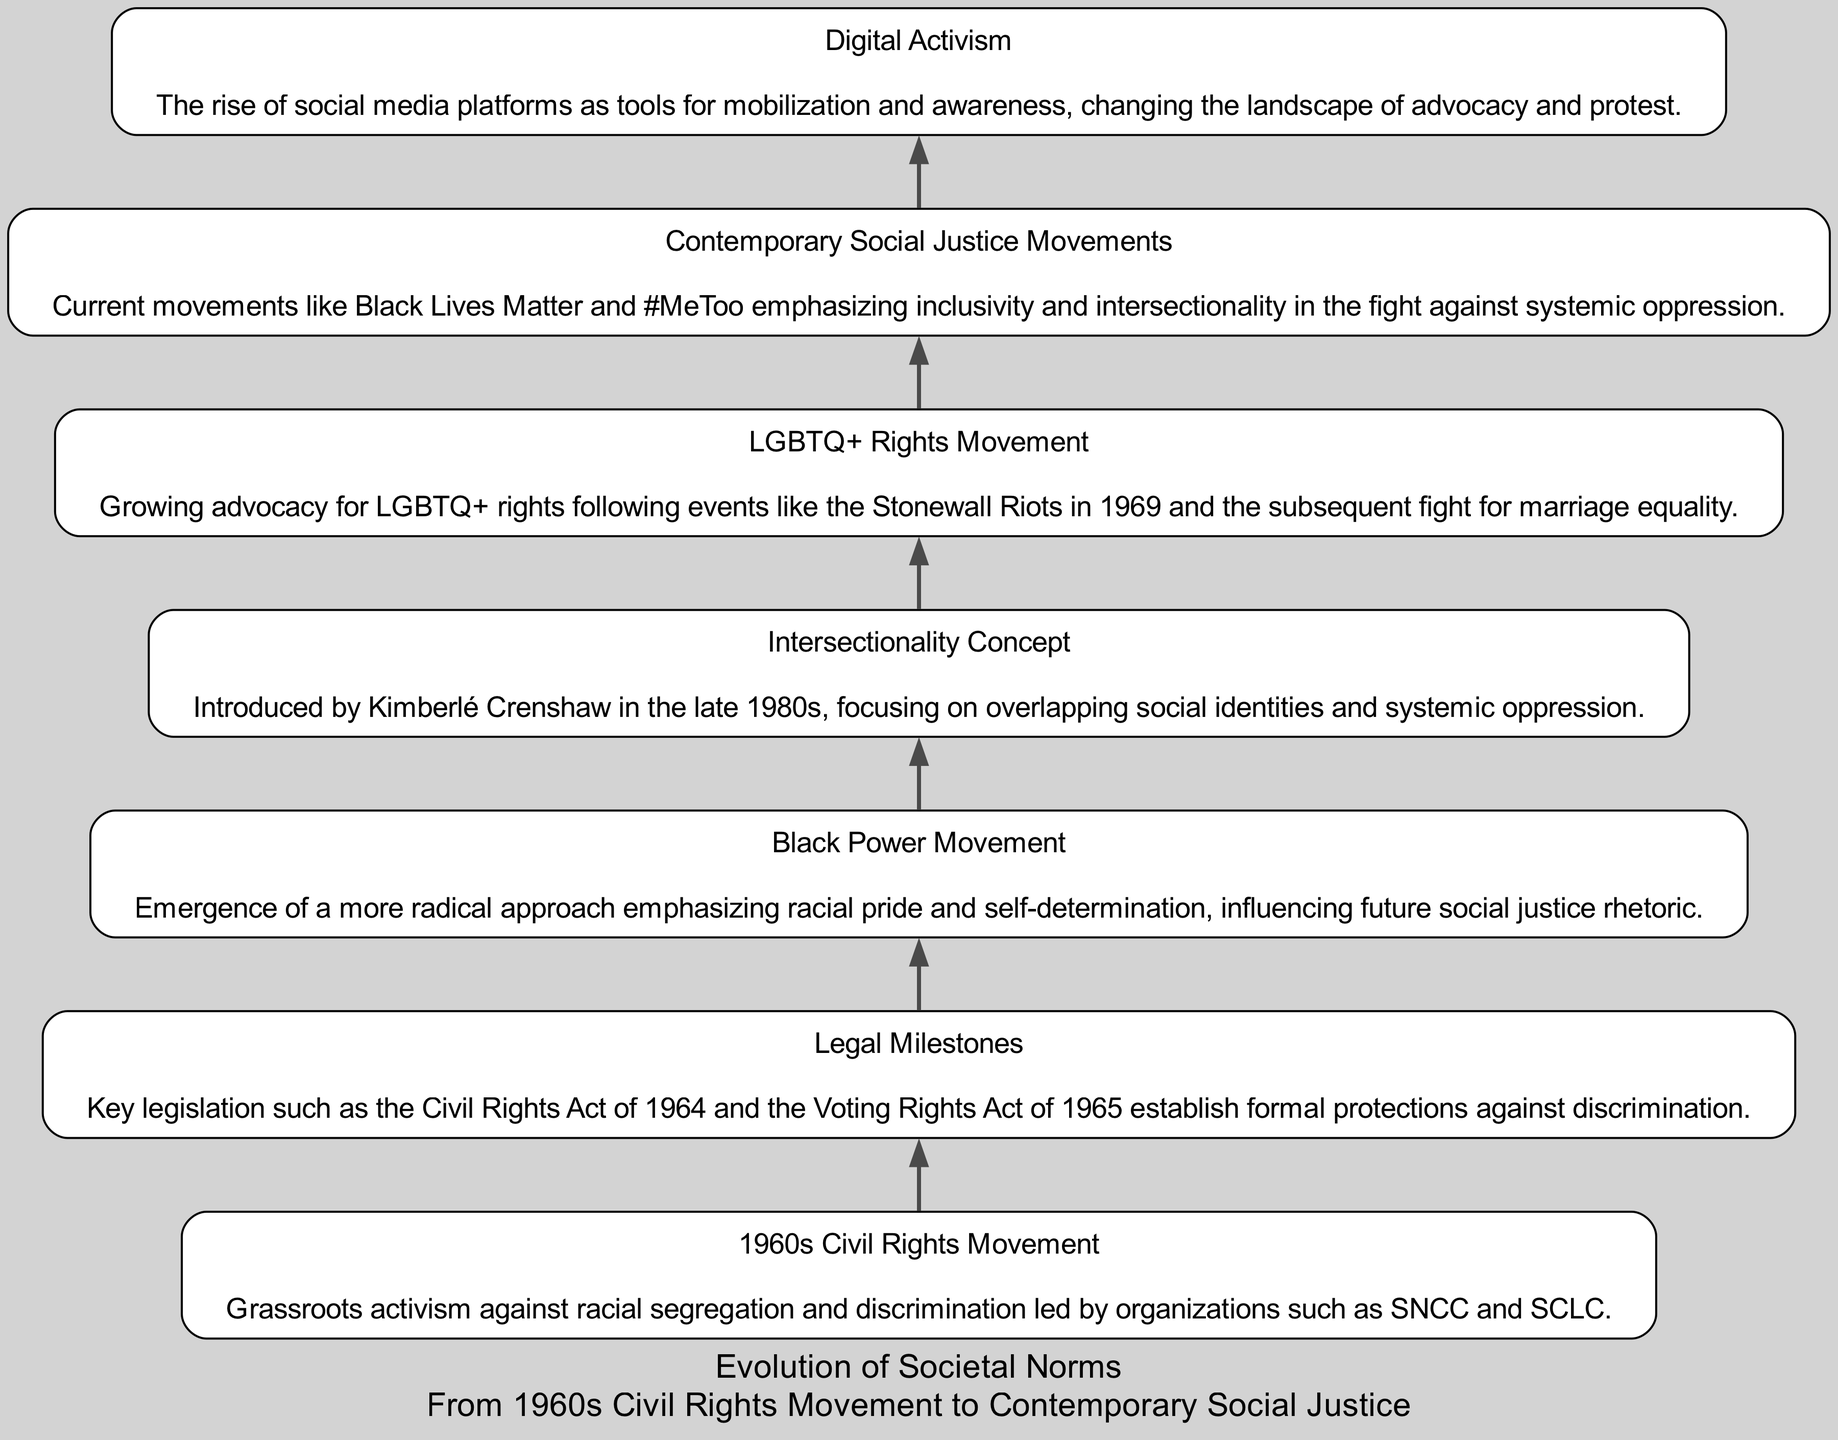What is the first node in the flow chart? The first node listed in the data corresponds to the "1960s Civil Rights Movement," which is the starting point of the diagram.
Answer: 1960s Civil Rights Movement How many nodes are present in the diagram? Counting each entry in the elements array, there are a total of seven nodes in the flow chart.
Answer: 7 Which node describes the concept introduced by Kimberlé Crenshaw? The node that mentions Kimberlé Crenshaw and her introduction of the concept is "Intersectionality Concept".
Answer: Intersectionality Concept What connects the "Black Power Movement" to "Legal Milestones"? The diagram flows sequentially, where "Black Power Movement" directly follows "Legal Milestones," suggesting a connection in the context of social progress.
Answer: The edge connecting the nodes What are the themes of the "Contemporary Social Justice Movements"? The node labeled "Contemporary Social Justice Movements" emphasizes inclusivity and intersectionality, reflecting modern themes in advocacy.
Answer: Inclusivity and intersectionality How does "Digital Activism" relate to "Contemporary Social Justice Movements"? "Digital Activism" is positioned below "Contemporary Social Justice Movements" in the diagram, indicating that the former serves as a tool for enhancing the latter's efforts.
Answer: Provides tools for mobilization Which node emphasizes a grassroots approach? The node "1960s Civil Rights Movement" explicitly describes a grassroots activism approach against racial segregation and discrimination.
Answer: 1960s Civil Rights Movement What is the significance of the "Black Power Movement" in relation to future movements? The description indicates that it influenced the rhetoric of future social justice movements by emphasizing racial pride and self-determination.
Answer: Influenced future social justice rhetoric What kind of movements follow after the "LGBTQ+ Rights Movement"? The flow of the chart indicates that both "Intersectionality Concept" and "Contemporary Social Justice Movements" follow after "LGBTQ+ Rights Movement," suggesting a continuation of advocacy themes.
Answer: Intersectionality Concept and Contemporary Social Justice Movements 